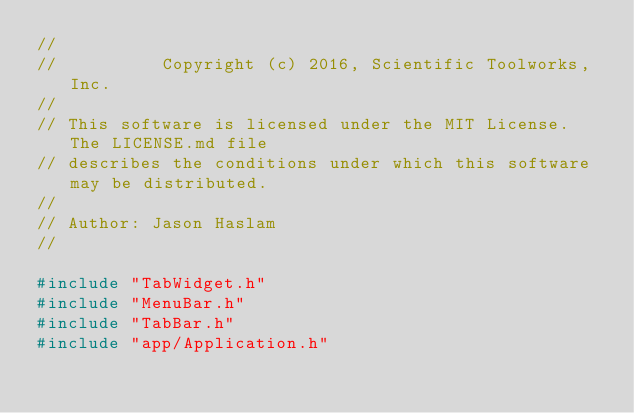Convert code to text. <code><loc_0><loc_0><loc_500><loc_500><_C++_>//
//          Copyright (c) 2016, Scientific Toolworks, Inc.
//
// This software is licensed under the MIT License. The LICENSE.md file
// describes the conditions under which this software may be distributed.
//
// Author: Jason Haslam
//

#include "TabWidget.h"
#include "MenuBar.h"
#include "TabBar.h"
#include "app/Application.h"</code> 